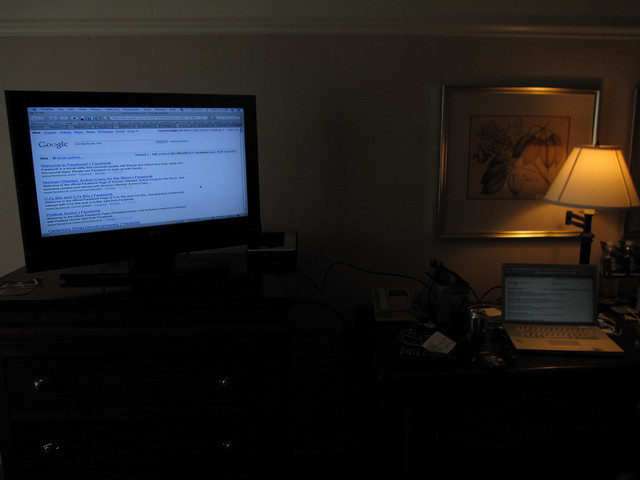Please transcribe the text information in this image. GOOGLE 